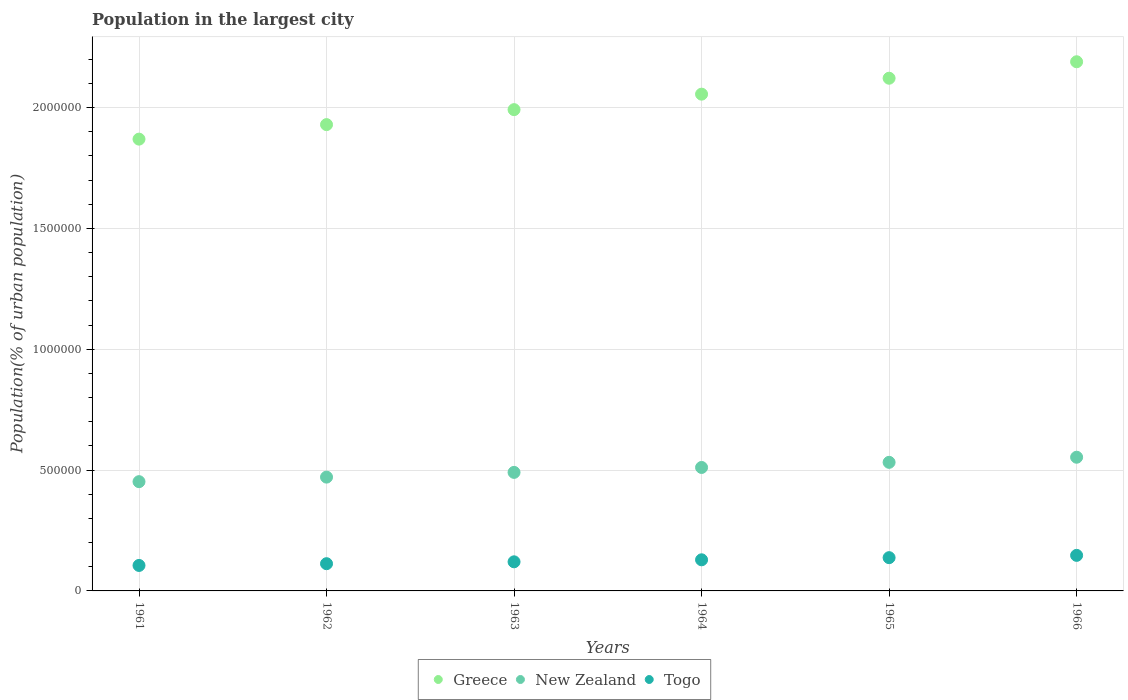How many different coloured dotlines are there?
Your response must be concise. 3. What is the population in the largest city in Greece in 1964?
Provide a succinct answer. 2.06e+06. Across all years, what is the maximum population in the largest city in Togo?
Offer a terse response. 1.47e+05. Across all years, what is the minimum population in the largest city in Greece?
Provide a succinct answer. 1.87e+06. In which year was the population in the largest city in Greece maximum?
Your answer should be very brief. 1966. In which year was the population in the largest city in New Zealand minimum?
Keep it short and to the point. 1961. What is the total population in the largest city in New Zealand in the graph?
Your answer should be compact. 3.01e+06. What is the difference between the population in the largest city in New Zealand in 1961 and that in 1966?
Ensure brevity in your answer.  -1.01e+05. What is the difference between the population in the largest city in Togo in 1966 and the population in the largest city in New Zealand in 1964?
Provide a short and direct response. -3.64e+05. What is the average population in the largest city in Togo per year?
Your response must be concise. 1.25e+05. In the year 1964, what is the difference between the population in the largest city in Togo and population in the largest city in Greece?
Your answer should be compact. -1.93e+06. In how many years, is the population in the largest city in Togo greater than 500000 %?
Provide a succinct answer. 0. What is the ratio of the population in the largest city in Togo in 1964 to that in 1966?
Ensure brevity in your answer.  0.88. Is the population in the largest city in Togo in 1962 less than that in 1964?
Your answer should be compact. Yes. What is the difference between the highest and the second highest population in the largest city in Togo?
Give a very brief answer. 9485. What is the difference between the highest and the lowest population in the largest city in Togo?
Give a very brief answer. 4.17e+04. In how many years, is the population in the largest city in Togo greater than the average population in the largest city in Togo taken over all years?
Offer a terse response. 3. Is the population in the largest city in New Zealand strictly greater than the population in the largest city in Greece over the years?
Your answer should be compact. No. Is the population in the largest city in Togo strictly less than the population in the largest city in New Zealand over the years?
Give a very brief answer. Yes. How many dotlines are there?
Your response must be concise. 3. What is the difference between two consecutive major ticks on the Y-axis?
Make the answer very short. 5.00e+05. Does the graph contain grids?
Ensure brevity in your answer.  Yes. Where does the legend appear in the graph?
Make the answer very short. Bottom center. How many legend labels are there?
Keep it short and to the point. 3. How are the legend labels stacked?
Your answer should be compact. Horizontal. What is the title of the graph?
Provide a short and direct response. Population in the largest city. What is the label or title of the X-axis?
Give a very brief answer. Years. What is the label or title of the Y-axis?
Ensure brevity in your answer.  Population(% of urban population). What is the Population(% of urban population) of Greece in 1961?
Your answer should be compact. 1.87e+06. What is the Population(% of urban population) in New Zealand in 1961?
Your answer should be compact. 4.52e+05. What is the Population(% of urban population) of Togo in 1961?
Ensure brevity in your answer.  1.05e+05. What is the Population(% of urban population) of Greece in 1962?
Give a very brief answer. 1.93e+06. What is the Population(% of urban population) in New Zealand in 1962?
Your answer should be very brief. 4.71e+05. What is the Population(% of urban population) of Togo in 1962?
Provide a succinct answer. 1.13e+05. What is the Population(% of urban population) of Greece in 1963?
Ensure brevity in your answer.  1.99e+06. What is the Population(% of urban population) of New Zealand in 1963?
Give a very brief answer. 4.90e+05. What is the Population(% of urban population) of Togo in 1963?
Provide a succinct answer. 1.20e+05. What is the Population(% of urban population) in Greece in 1964?
Your answer should be very brief. 2.06e+06. What is the Population(% of urban population) in New Zealand in 1964?
Keep it short and to the point. 5.11e+05. What is the Population(% of urban population) in Togo in 1964?
Offer a very short reply. 1.29e+05. What is the Population(% of urban population) of Greece in 1965?
Offer a terse response. 2.12e+06. What is the Population(% of urban population) in New Zealand in 1965?
Provide a succinct answer. 5.32e+05. What is the Population(% of urban population) of Togo in 1965?
Your answer should be compact. 1.38e+05. What is the Population(% of urban population) in Greece in 1966?
Provide a succinct answer. 2.19e+06. What is the Population(% of urban population) in New Zealand in 1966?
Give a very brief answer. 5.53e+05. What is the Population(% of urban population) in Togo in 1966?
Offer a terse response. 1.47e+05. Across all years, what is the maximum Population(% of urban population) of Greece?
Your answer should be compact. 2.19e+06. Across all years, what is the maximum Population(% of urban population) of New Zealand?
Ensure brevity in your answer.  5.53e+05. Across all years, what is the maximum Population(% of urban population) of Togo?
Provide a short and direct response. 1.47e+05. Across all years, what is the minimum Population(% of urban population) in Greece?
Make the answer very short. 1.87e+06. Across all years, what is the minimum Population(% of urban population) in New Zealand?
Make the answer very short. 4.52e+05. Across all years, what is the minimum Population(% of urban population) in Togo?
Make the answer very short. 1.05e+05. What is the total Population(% of urban population) of Greece in the graph?
Your answer should be very brief. 1.22e+07. What is the total Population(% of urban population) in New Zealand in the graph?
Offer a terse response. 3.01e+06. What is the total Population(% of urban population) in Togo in the graph?
Offer a terse response. 7.52e+05. What is the difference between the Population(% of urban population) in Greece in 1961 and that in 1962?
Keep it short and to the point. -6.00e+04. What is the difference between the Population(% of urban population) in New Zealand in 1961 and that in 1962?
Give a very brief answer. -1.88e+04. What is the difference between the Population(% of urban population) in Togo in 1961 and that in 1962?
Keep it short and to the point. -7266. What is the difference between the Population(% of urban population) in Greece in 1961 and that in 1963?
Keep it short and to the point. -1.22e+05. What is the difference between the Population(% of urban population) of New Zealand in 1961 and that in 1963?
Make the answer very short. -3.83e+04. What is the difference between the Population(% of urban population) in Togo in 1961 and that in 1963?
Provide a short and direct response. -1.50e+04. What is the difference between the Population(% of urban population) of Greece in 1961 and that in 1964?
Provide a succinct answer. -1.86e+05. What is the difference between the Population(% of urban population) of New Zealand in 1961 and that in 1964?
Offer a very short reply. -5.87e+04. What is the difference between the Population(% of urban population) of Togo in 1961 and that in 1964?
Ensure brevity in your answer.  -2.33e+04. What is the difference between the Population(% of urban population) of Greece in 1961 and that in 1965?
Offer a terse response. -2.52e+05. What is the difference between the Population(% of urban population) of New Zealand in 1961 and that in 1965?
Make the answer very short. -7.99e+04. What is the difference between the Population(% of urban population) in Togo in 1961 and that in 1965?
Your answer should be very brief. -3.22e+04. What is the difference between the Population(% of urban population) of Greece in 1961 and that in 1966?
Provide a short and direct response. -3.20e+05. What is the difference between the Population(% of urban population) of New Zealand in 1961 and that in 1966?
Your response must be concise. -1.01e+05. What is the difference between the Population(% of urban population) of Togo in 1961 and that in 1966?
Give a very brief answer. -4.17e+04. What is the difference between the Population(% of urban population) in Greece in 1962 and that in 1963?
Keep it short and to the point. -6.20e+04. What is the difference between the Population(% of urban population) in New Zealand in 1962 and that in 1963?
Offer a very short reply. -1.96e+04. What is the difference between the Population(% of urban population) in Togo in 1962 and that in 1963?
Your response must be concise. -7766. What is the difference between the Population(% of urban population) of Greece in 1962 and that in 1964?
Make the answer very short. -1.26e+05. What is the difference between the Population(% of urban population) in New Zealand in 1962 and that in 1964?
Make the answer very short. -4.00e+04. What is the difference between the Population(% of urban population) of Togo in 1962 and that in 1964?
Your answer should be compact. -1.61e+04. What is the difference between the Population(% of urban population) of Greece in 1962 and that in 1965?
Keep it short and to the point. -1.92e+05. What is the difference between the Population(% of urban population) in New Zealand in 1962 and that in 1965?
Provide a short and direct response. -6.12e+04. What is the difference between the Population(% of urban population) in Togo in 1962 and that in 1965?
Ensure brevity in your answer.  -2.49e+04. What is the difference between the Population(% of urban population) of Greece in 1962 and that in 1966?
Offer a very short reply. -2.60e+05. What is the difference between the Population(% of urban population) in New Zealand in 1962 and that in 1966?
Your answer should be compact. -8.23e+04. What is the difference between the Population(% of urban population) in Togo in 1962 and that in 1966?
Offer a terse response. -3.44e+04. What is the difference between the Population(% of urban population) of Greece in 1963 and that in 1964?
Provide a succinct answer. -6.40e+04. What is the difference between the Population(% of urban population) in New Zealand in 1963 and that in 1964?
Give a very brief answer. -2.04e+04. What is the difference between the Population(% of urban population) of Togo in 1963 and that in 1964?
Offer a terse response. -8313. What is the difference between the Population(% of urban population) of Greece in 1963 and that in 1965?
Keep it short and to the point. -1.30e+05. What is the difference between the Population(% of urban population) in New Zealand in 1963 and that in 1965?
Make the answer very short. -4.16e+04. What is the difference between the Population(% of urban population) of Togo in 1963 and that in 1965?
Keep it short and to the point. -1.72e+04. What is the difference between the Population(% of urban population) in Greece in 1963 and that in 1966?
Make the answer very short. -1.98e+05. What is the difference between the Population(% of urban population) in New Zealand in 1963 and that in 1966?
Your response must be concise. -6.27e+04. What is the difference between the Population(% of urban population) of Togo in 1963 and that in 1966?
Provide a short and direct response. -2.67e+04. What is the difference between the Population(% of urban population) of Greece in 1964 and that in 1965?
Make the answer very short. -6.59e+04. What is the difference between the Population(% of urban population) of New Zealand in 1964 and that in 1965?
Offer a terse response. -2.12e+04. What is the difference between the Population(% of urban population) of Togo in 1964 and that in 1965?
Ensure brevity in your answer.  -8863. What is the difference between the Population(% of urban population) in Greece in 1964 and that in 1966?
Your answer should be compact. -1.34e+05. What is the difference between the Population(% of urban population) in New Zealand in 1964 and that in 1966?
Your answer should be very brief. -4.23e+04. What is the difference between the Population(% of urban population) in Togo in 1964 and that in 1966?
Your answer should be compact. -1.83e+04. What is the difference between the Population(% of urban population) in Greece in 1965 and that in 1966?
Give a very brief answer. -6.81e+04. What is the difference between the Population(% of urban population) in New Zealand in 1965 and that in 1966?
Offer a very short reply. -2.11e+04. What is the difference between the Population(% of urban population) of Togo in 1965 and that in 1966?
Provide a short and direct response. -9485. What is the difference between the Population(% of urban population) of Greece in 1961 and the Population(% of urban population) of New Zealand in 1962?
Ensure brevity in your answer.  1.40e+06. What is the difference between the Population(% of urban population) in Greece in 1961 and the Population(% of urban population) in Togo in 1962?
Offer a very short reply. 1.76e+06. What is the difference between the Population(% of urban population) in New Zealand in 1961 and the Population(% of urban population) in Togo in 1962?
Make the answer very short. 3.39e+05. What is the difference between the Population(% of urban population) of Greece in 1961 and the Population(% of urban population) of New Zealand in 1963?
Provide a short and direct response. 1.38e+06. What is the difference between the Population(% of urban population) of Greece in 1961 and the Population(% of urban population) of Togo in 1963?
Keep it short and to the point. 1.75e+06. What is the difference between the Population(% of urban population) in New Zealand in 1961 and the Population(% of urban population) in Togo in 1963?
Give a very brief answer. 3.32e+05. What is the difference between the Population(% of urban population) of Greece in 1961 and the Population(% of urban population) of New Zealand in 1964?
Your answer should be very brief. 1.36e+06. What is the difference between the Population(% of urban population) of Greece in 1961 and the Population(% of urban population) of Togo in 1964?
Make the answer very short. 1.74e+06. What is the difference between the Population(% of urban population) of New Zealand in 1961 and the Population(% of urban population) of Togo in 1964?
Ensure brevity in your answer.  3.23e+05. What is the difference between the Population(% of urban population) in Greece in 1961 and the Population(% of urban population) in New Zealand in 1965?
Give a very brief answer. 1.34e+06. What is the difference between the Population(% of urban population) of Greece in 1961 and the Population(% of urban population) of Togo in 1965?
Ensure brevity in your answer.  1.73e+06. What is the difference between the Population(% of urban population) in New Zealand in 1961 and the Population(% of urban population) in Togo in 1965?
Keep it short and to the point. 3.14e+05. What is the difference between the Population(% of urban population) in Greece in 1961 and the Population(% of urban population) in New Zealand in 1966?
Ensure brevity in your answer.  1.32e+06. What is the difference between the Population(% of urban population) of Greece in 1961 and the Population(% of urban population) of Togo in 1966?
Provide a succinct answer. 1.72e+06. What is the difference between the Population(% of urban population) of New Zealand in 1961 and the Population(% of urban population) of Togo in 1966?
Offer a very short reply. 3.05e+05. What is the difference between the Population(% of urban population) of Greece in 1962 and the Population(% of urban population) of New Zealand in 1963?
Offer a terse response. 1.44e+06. What is the difference between the Population(% of urban population) of Greece in 1962 and the Population(% of urban population) of Togo in 1963?
Your answer should be compact. 1.81e+06. What is the difference between the Population(% of urban population) of New Zealand in 1962 and the Population(% of urban population) of Togo in 1963?
Keep it short and to the point. 3.50e+05. What is the difference between the Population(% of urban population) in Greece in 1962 and the Population(% of urban population) in New Zealand in 1964?
Make the answer very short. 1.42e+06. What is the difference between the Population(% of urban population) in Greece in 1962 and the Population(% of urban population) in Togo in 1964?
Your answer should be compact. 1.80e+06. What is the difference between the Population(% of urban population) of New Zealand in 1962 and the Population(% of urban population) of Togo in 1964?
Make the answer very short. 3.42e+05. What is the difference between the Population(% of urban population) in Greece in 1962 and the Population(% of urban population) in New Zealand in 1965?
Keep it short and to the point. 1.40e+06. What is the difference between the Population(% of urban population) of Greece in 1962 and the Population(% of urban population) of Togo in 1965?
Provide a succinct answer. 1.79e+06. What is the difference between the Population(% of urban population) of New Zealand in 1962 and the Population(% of urban population) of Togo in 1965?
Keep it short and to the point. 3.33e+05. What is the difference between the Population(% of urban population) of Greece in 1962 and the Population(% of urban population) of New Zealand in 1966?
Your answer should be compact. 1.38e+06. What is the difference between the Population(% of urban population) in Greece in 1962 and the Population(% of urban population) in Togo in 1966?
Make the answer very short. 1.78e+06. What is the difference between the Population(% of urban population) of New Zealand in 1962 and the Population(% of urban population) of Togo in 1966?
Give a very brief answer. 3.24e+05. What is the difference between the Population(% of urban population) in Greece in 1963 and the Population(% of urban population) in New Zealand in 1964?
Provide a succinct answer. 1.48e+06. What is the difference between the Population(% of urban population) of Greece in 1963 and the Population(% of urban population) of Togo in 1964?
Make the answer very short. 1.86e+06. What is the difference between the Population(% of urban population) of New Zealand in 1963 and the Population(% of urban population) of Togo in 1964?
Provide a short and direct response. 3.62e+05. What is the difference between the Population(% of urban population) in Greece in 1963 and the Population(% of urban population) in New Zealand in 1965?
Your answer should be compact. 1.46e+06. What is the difference between the Population(% of urban population) of Greece in 1963 and the Population(% of urban population) of Togo in 1965?
Offer a terse response. 1.85e+06. What is the difference between the Population(% of urban population) of New Zealand in 1963 and the Population(% of urban population) of Togo in 1965?
Your response must be concise. 3.53e+05. What is the difference between the Population(% of urban population) in Greece in 1963 and the Population(% of urban population) in New Zealand in 1966?
Keep it short and to the point. 1.44e+06. What is the difference between the Population(% of urban population) in Greece in 1963 and the Population(% of urban population) in Togo in 1966?
Your answer should be very brief. 1.84e+06. What is the difference between the Population(% of urban population) in New Zealand in 1963 and the Population(% of urban population) in Togo in 1966?
Provide a succinct answer. 3.43e+05. What is the difference between the Population(% of urban population) in Greece in 1964 and the Population(% of urban population) in New Zealand in 1965?
Give a very brief answer. 1.52e+06. What is the difference between the Population(% of urban population) in Greece in 1964 and the Population(% of urban population) in Togo in 1965?
Provide a short and direct response. 1.92e+06. What is the difference between the Population(% of urban population) in New Zealand in 1964 and the Population(% of urban population) in Togo in 1965?
Provide a short and direct response. 3.73e+05. What is the difference between the Population(% of urban population) in Greece in 1964 and the Population(% of urban population) in New Zealand in 1966?
Your answer should be very brief. 1.50e+06. What is the difference between the Population(% of urban population) in Greece in 1964 and the Population(% of urban population) in Togo in 1966?
Your answer should be compact. 1.91e+06. What is the difference between the Population(% of urban population) in New Zealand in 1964 and the Population(% of urban population) in Togo in 1966?
Provide a succinct answer. 3.64e+05. What is the difference between the Population(% of urban population) of Greece in 1965 and the Population(% of urban population) of New Zealand in 1966?
Provide a short and direct response. 1.57e+06. What is the difference between the Population(% of urban population) of Greece in 1965 and the Population(% of urban population) of Togo in 1966?
Your answer should be compact. 1.97e+06. What is the difference between the Population(% of urban population) of New Zealand in 1965 and the Population(% of urban population) of Togo in 1966?
Your answer should be very brief. 3.85e+05. What is the average Population(% of urban population) of Greece per year?
Your response must be concise. 2.03e+06. What is the average Population(% of urban population) in New Zealand per year?
Offer a very short reply. 5.02e+05. What is the average Population(% of urban population) of Togo per year?
Offer a very short reply. 1.25e+05. In the year 1961, what is the difference between the Population(% of urban population) in Greece and Population(% of urban population) in New Zealand?
Offer a terse response. 1.42e+06. In the year 1961, what is the difference between the Population(% of urban population) in Greece and Population(% of urban population) in Togo?
Give a very brief answer. 1.76e+06. In the year 1961, what is the difference between the Population(% of urban population) in New Zealand and Population(% of urban population) in Togo?
Offer a very short reply. 3.47e+05. In the year 1962, what is the difference between the Population(% of urban population) of Greece and Population(% of urban population) of New Zealand?
Make the answer very short. 1.46e+06. In the year 1962, what is the difference between the Population(% of urban population) of Greece and Population(% of urban population) of Togo?
Your answer should be very brief. 1.82e+06. In the year 1962, what is the difference between the Population(% of urban population) in New Zealand and Population(% of urban population) in Togo?
Offer a terse response. 3.58e+05. In the year 1963, what is the difference between the Population(% of urban population) in Greece and Population(% of urban population) in New Zealand?
Keep it short and to the point. 1.50e+06. In the year 1963, what is the difference between the Population(% of urban population) in Greece and Population(% of urban population) in Togo?
Your answer should be compact. 1.87e+06. In the year 1963, what is the difference between the Population(% of urban population) of New Zealand and Population(% of urban population) of Togo?
Your response must be concise. 3.70e+05. In the year 1964, what is the difference between the Population(% of urban population) in Greece and Population(% of urban population) in New Zealand?
Make the answer very short. 1.54e+06. In the year 1964, what is the difference between the Population(% of urban population) in Greece and Population(% of urban population) in Togo?
Offer a very short reply. 1.93e+06. In the year 1964, what is the difference between the Population(% of urban population) of New Zealand and Population(% of urban population) of Togo?
Your answer should be compact. 3.82e+05. In the year 1965, what is the difference between the Population(% of urban population) of Greece and Population(% of urban population) of New Zealand?
Ensure brevity in your answer.  1.59e+06. In the year 1965, what is the difference between the Population(% of urban population) in Greece and Population(% of urban population) in Togo?
Give a very brief answer. 1.98e+06. In the year 1965, what is the difference between the Population(% of urban population) in New Zealand and Population(% of urban population) in Togo?
Your answer should be compact. 3.94e+05. In the year 1966, what is the difference between the Population(% of urban population) in Greece and Population(% of urban population) in New Zealand?
Your response must be concise. 1.64e+06. In the year 1966, what is the difference between the Population(% of urban population) of Greece and Population(% of urban population) of Togo?
Make the answer very short. 2.04e+06. In the year 1966, what is the difference between the Population(% of urban population) of New Zealand and Population(% of urban population) of Togo?
Give a very brief answer. 4.06e+05. What is the ratio of the Population(% of urban population) in Greece in 1961 to that in 1962?
Ensure brevity in your answer.  0.97. What is the ratio of the Population(% of urban population) in New Zealand in 1961 to that in 1962?
Keep it short and to the point. 0.96. What is the ratio of the Population(% of urban population) in Togo in 1961 to that in 1962?
Make the answer very short. 0.94. What is the ratio of the Population(% of urban population) of Greece in 1961 to that in 1963?
Ensure brevity in your answer.  0.94. What is the ratio of the Population(% of urban population) in New Zealand in 1961 to that in 1963?
Make the answer very short. 0.92. What is the ratio of the Population(% of urban population) in Togo in 1961 to that in 1963?
Offer a terse response. 0.88. What is the ratio of the Population(% of urban population) of Greece in 1961 to that in 1964?
Provide a succinct answer. 0.91. What is the ratio of the Population(% of urban population) in New Zealand in 1961 to that in 1964?
Offer a very short reply. 0.89. What is the ratio of the Population(% of urban population) of Togo in 1961 to that in 1964?
Provide a succinct answer. 0.82. What is the ratio of the Population(% of urban population) of Greece in 1961 to that in 1965?
Give a very brief answer. 0.88. What is the ratio of the Population(% of urban population) of New Zealand in 1961 to that in 1965?
Keep it short and to the point. 0.85. What is the ratio of the Population(% of urban population) of Togo in 1961 to that in 1965?
Offer a terse response. 0.77. What is the ratio of the Population(% of urban population) of Greece in 1961 to that in 1966?
Your answer should be compact. 0.85. What is the ratio of the Population(% of urban population) of New Zealand in 1961 to that in 1966?
Keep it short and to the point. 0.82. What is the ratio of the Population(% of urban population) of Togo in 1961 to that in 1966?
Give a very brief answer. 0.72. What is the ratio of the Population(% of urban population) in Greece in 1962 to that in 1963?
Provide a succinct answer. 0.97. What is the ratio of the Population(% of urban population) in New Zealand in 1962 to that in 1963?
Make the answer very short. 0.96. What is the ratio of the Population(% of urban population) of Togo in 1962 to that in 1963?
Keep it short and to the point. 0.94. What is the ratio of the Population(% of urban population) of Greece in 1962 to that in 1964?
Give a very brief answer. 0.94. What is the ratio of the Population(% of urban population) of New Zealand in 1962 to that in 1964?
Your response must be concise. 0.92. What is the ratio of the Population(% of urban population) of Togo in 1962 to that in 1964?
Ensure brevity in your answer.  0.88. What is the ratio of the Population(% of urban population) in Greece in 1962 to that in 1965?
Offer a terse response. 0.91. What is the ratio of the Population(% of urban population) of New Zealand in 1962 to that in 1965?
Provide a succinct answer. 0.89. What is the ratio of the Population(% of urban population) of Togo in 1962 to that in 1965?
Ensure brevity in your answer.  0.82. What is the ratio of the Population(% of urban population) in Greece in 1962 to that in 1966?
Give a very brief answer. 0.88. What is the ratio of the Population(% of urban population) of New Zealand in 1962 to that in 1966?
Keep it short and to the point. 0.85. What is the ratio of the Population(% of urban population) in Togo in 1962 to that in 1966?
Your answer should be very brief. 0.77. What is the ratio of the Population(% of urban population) of Greece in 1963 to that in 1964?
Your answer should be compact. 0.97. What is the ratio of the Population(% of urban population) in New Zealand in 1963 to that in 1964?
Provide a succinct answer. 0.96. What is the ratio of the Population(% of urban population) of Togo in 1963 to that in 1964?
Your response must be concise. 0.94. What is the ratio of the Population(% of urban population) in Greece in 1963 to that in 1965?
Your answer should be very brief. 0.94. What is the ratio of the Population(% of urban population) in New Zealand in 1963 to that in 1965?
Offer a very short reply. 0.92. What is the ratio of the Population(% of urban population) of Togo in 1963 to that in 1965?
Provide a succinct answer. 0.88. What is the ratio of the Population(% of urban population) of Greece in 1963 to that in 1966?
Ensure brevity in your answer.  0.91. What is the ratio of the Population(% of urban population) of New Zealand in 1963 to that in 1966?
Provide a short and direct response. 0.89. What is the ratio of the Population(% of urban population) in Togo in 1963 to that in 1966?
Make the answer very short. 0.82. What is the ratio of the Population(% of urban population) in Greece in 1964 to that in 1965?
Give a very brief answer. 0.97. What is the ratio of the Population(% of urban population) of New Zealand in 1964 to that in 1965?
Provide a succinct answer. 0.96. What is the ratio of the Population(% of urban population) in Togo in 1964 to that in 1965?
Ensure brevity in your answer.  0.94. What is the ratio of the Population(% of urban population) in Greece in 1964 to that in 1966?
Provide a succinct answer. 0.94. What is the ratio of the Population(% of urban population) of New Zealand in 1964 to that in 1966?
Give a very brief answer. 0.92. What is the ratio of the Population(% of urban population) in Togo in 1964 to that in 1966?
Offer a very short reply. 0.88. What is the ratio of the Population(% of urban population) of Greece in 1965 to that in 1966?
Your answer should be very brief. 0.97. What is the ratio of the Population(% of urban population) in New Zealand in 1965 to that in 1966?
Keep it short and to the point. 0.96. What is the ratio of the Population(% of urban population) in Togo in 1965 to that in 1966?
Provide a short and direct response. 0.94. What is the difference between the highest and the second highest Population(% of urban population) in Greece?
Provide a short and direct response. 6.81e+04. What is the difference between the highest and the second highest Population(% of urban population) in New Zealand?
Your answer should be compact. 2.11e+04. What is the difference between the highest and the second highest Population(% of urban population) in Togo?
Give a very brief answer. 9485. What is the difference between the highest and the lowest Population(% of urban population) of Greece?
Your answer should be very brief. 3.20e+05. What is the difference between the highest and the lowest Population(% of urban population) in New Zealand?
Provide a succinct answer. 1.01e+05. What is the difference between the highest and the lowest Population(% of urban population) in Togo?
Ensure brevity in your answer.  4.17e+04. 